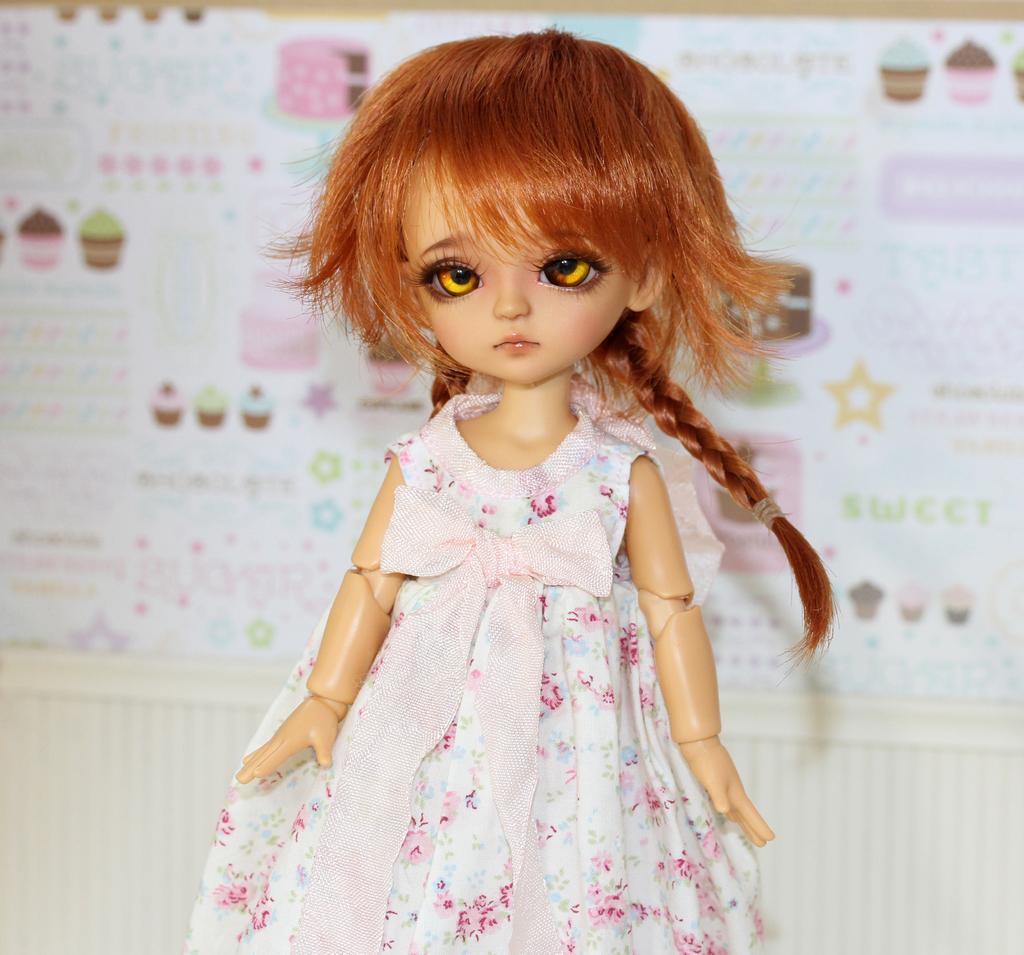Could you give a brief overview of what you see in this image? In this picture we can observe a doll. There is a white and pink color dress on the doll. We can observe brown color eyes and hair. In the background there is a chart. 